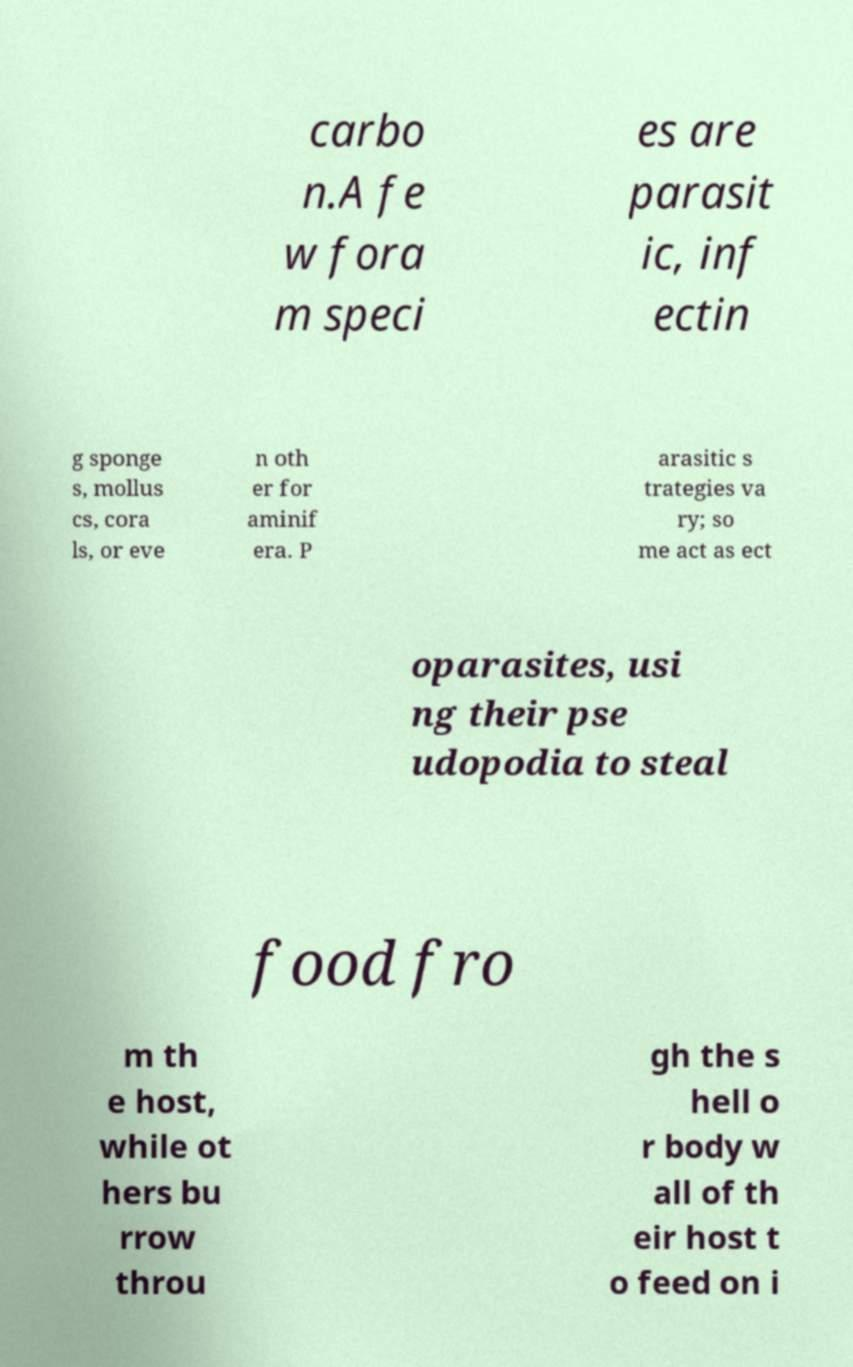What messages or text are displayed in this image? I need them in a readable, typed format. carbo n.A fe w fora m speci es are parasit ic, inf ectin g sponge s, mollus cs, cora ls, or eve n oth er for aminif era. P arasitic s trategies va ry; so me act as ect oparasites, usi ng their pse udopodia to steal food fro m th e host, while ot hers bu rrow throu gh the s hell o r body w all of th eir host t o feed on i 